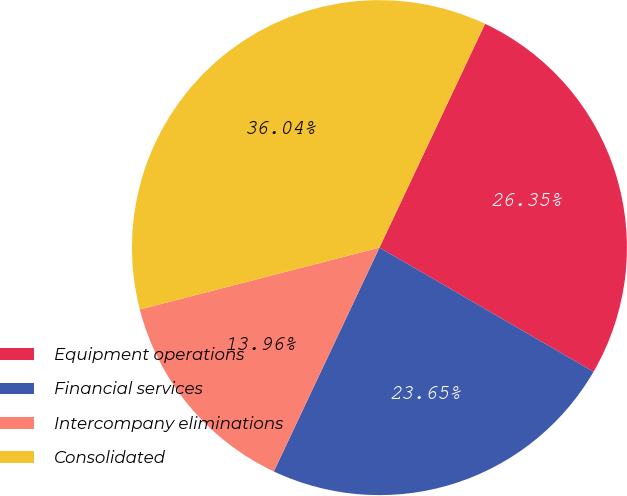Convert chart to OTSL. <chart><loc_0><loc_0><loc_500><loc_500><pie_chart><fcel>Equipment operations<fcel>Financial services<fcel>Intercompany eliminations<fcel>Consolidated<nl><fcel>26.35%<fcel>23.65%<fcel>13.96%<fcel>36.04%<nl></chart> 